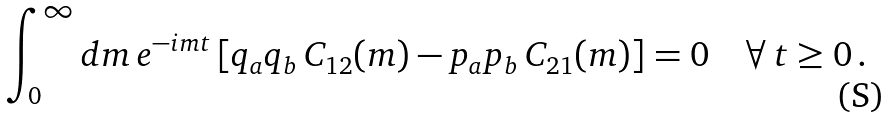<formula> <loc_0><loc_0><loc_500><loc_500>\int _ { 0 } ^ { \infty } d m \, e ^ { - i m t } \left [ q _ { a } q _ { b } \, C _ { 1 2 } ( m ) - p _ { a } p _ { b } \, C _ { 2 1 } ( m ) \right ] = 0 \quad \forall \, t \geq 0 \, .</formula> 